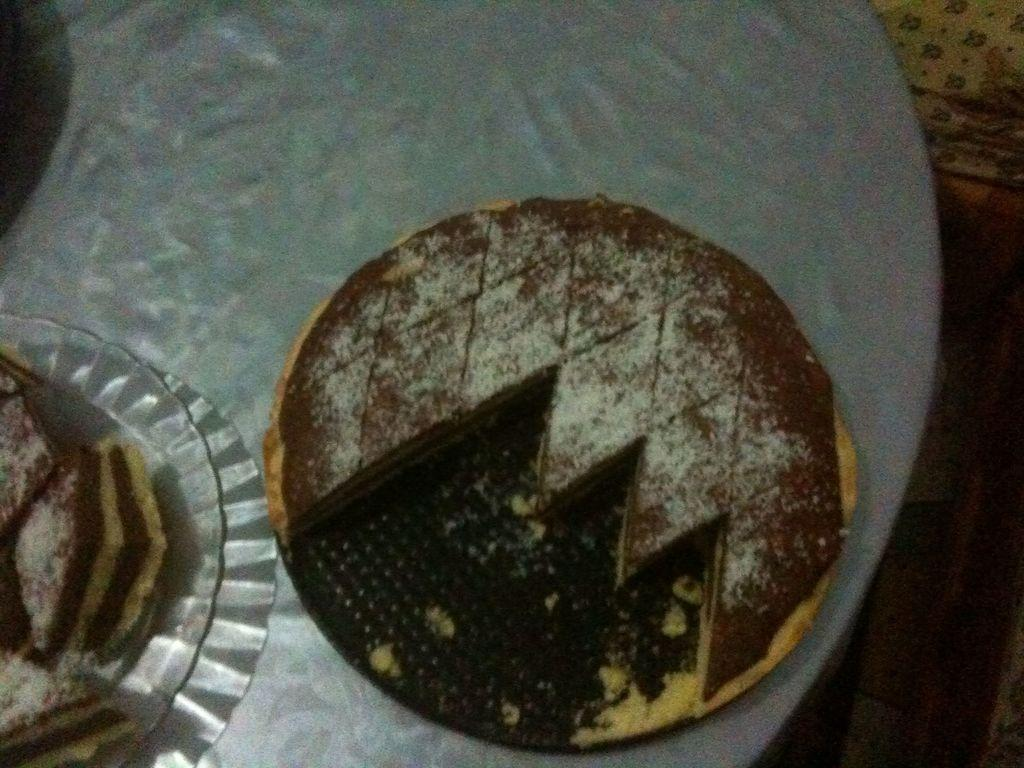What type of cake is in the image? There is a chocolate cake in the image. What color is the chocolate cake? The chocolate cake is brown in color. What is the color of the table top where the cake is placed? The table top is white in color. Where is the chocolate cake located in the image? The chocolate cake is placed on the table top. Can you see any visible veins on the chocolate cake in the image? There are no visible veins on the chocolate cake in the image, as it is a dessert and not a living organism. 